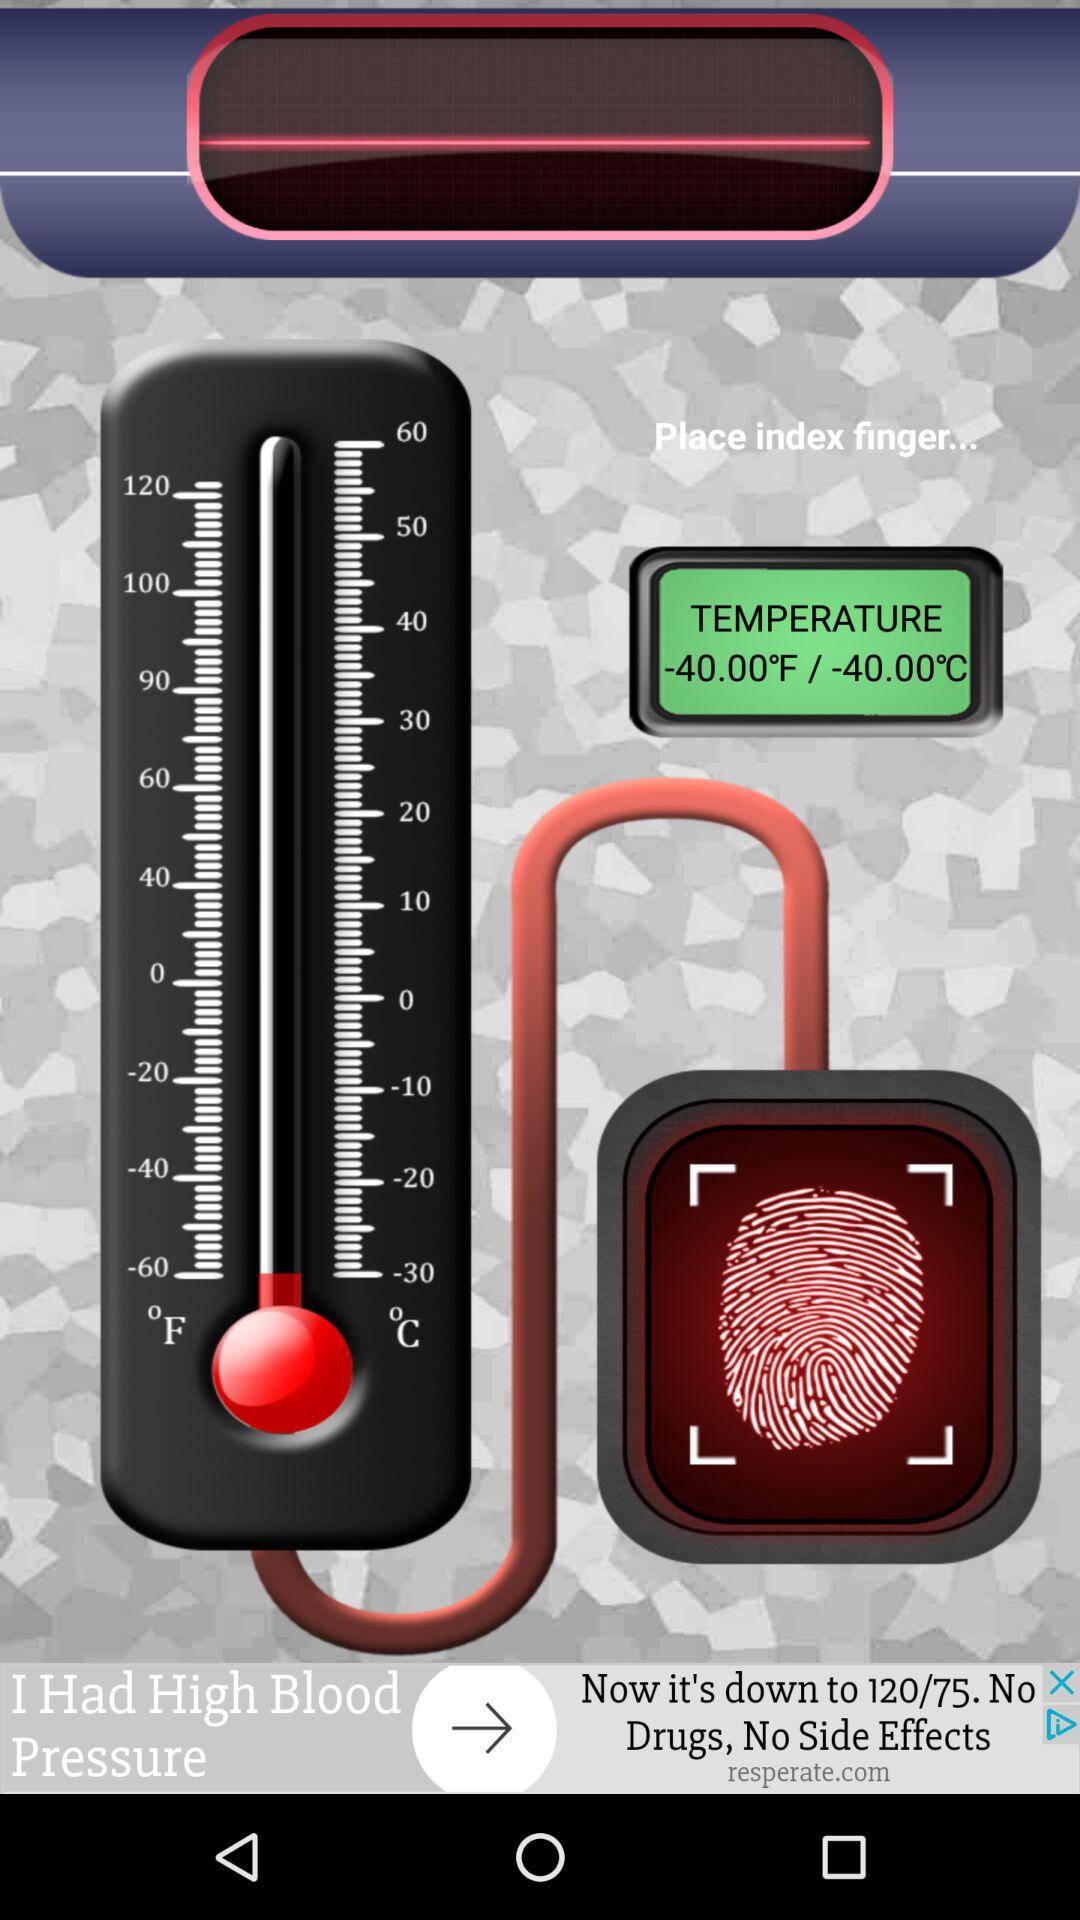How many degrees is the difference between the temperature at -30°F and the temperature at 0°F?
Answer the question using a single word or phrase. 30 